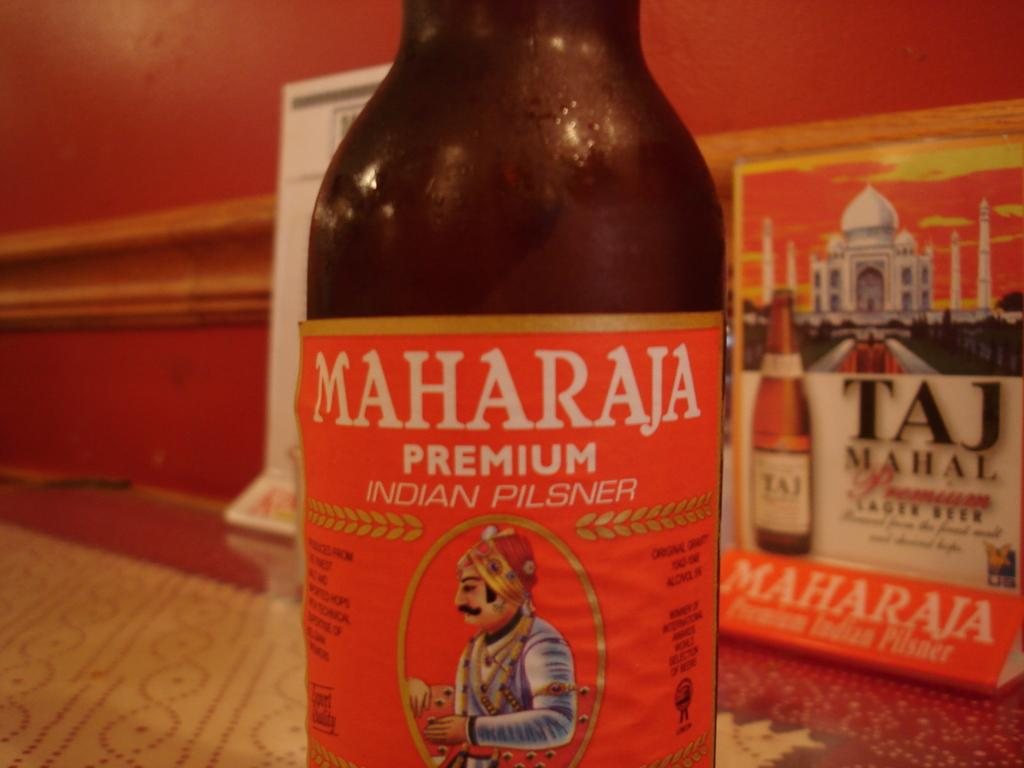<image>
Create a compact narrative representing the image presented. a bottle on a table with an orange label that says 'maharaja premium indian pilsner' 